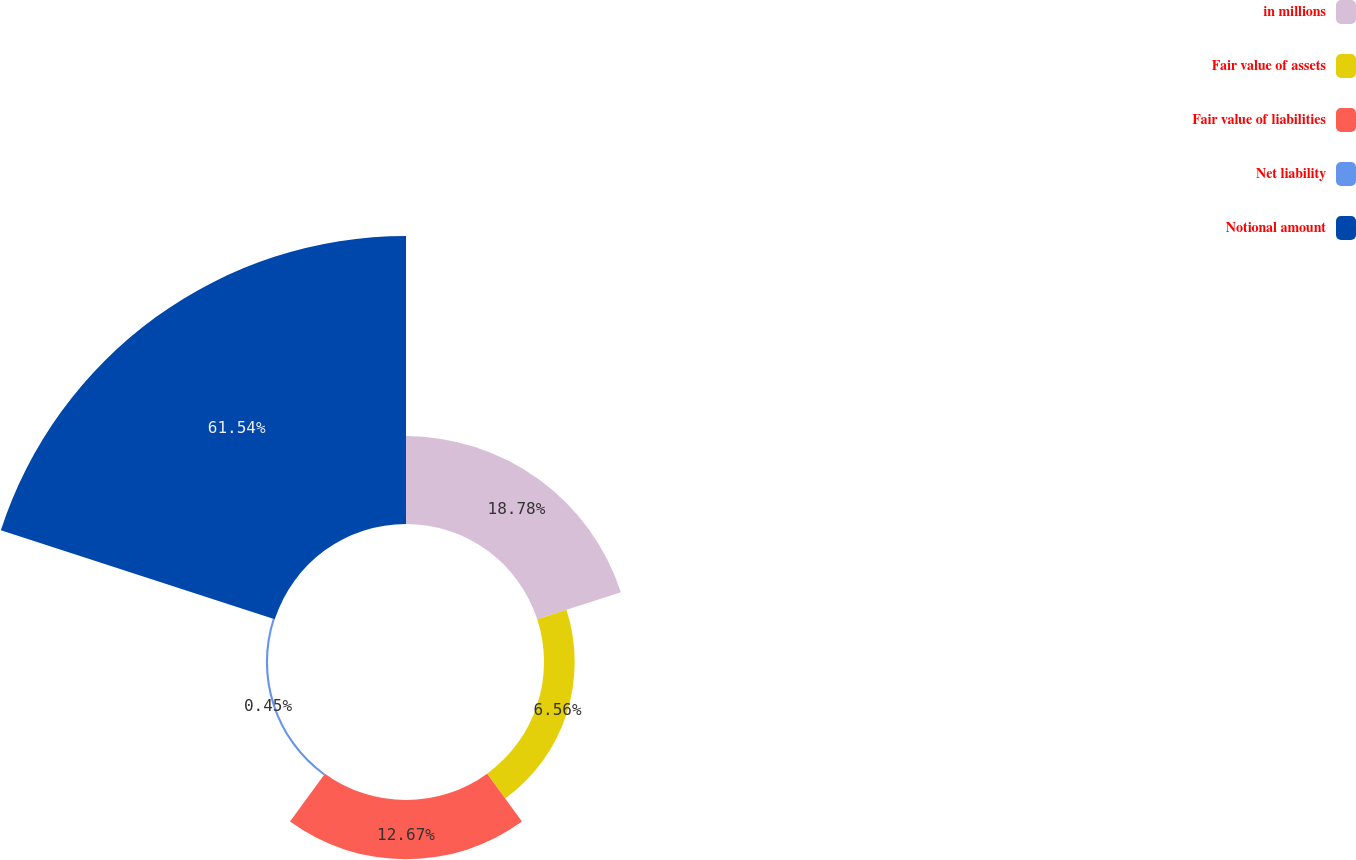Convert chart to OTSL. <chart><loc_0><loc_0><loc_500><loc_500><pie_chart><fcel>in millions<fcel>Fair value of assets<fcel>Fair value of liabilities<fcel>Net liability<fcel>Notional amount<nl><fcel>18.78%<fcel>6.56%<fcel>12.67%<fcel>0.45%<fcel>61.53%<nl></chart> 